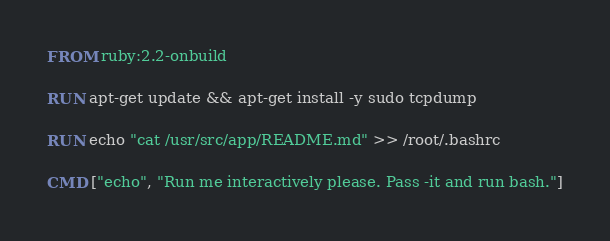Convert code to text. <code><loc_0><loc_0><loc_500><loc_500><_Dockerfile_>FROM ruby:2.2-onbuild

RUN apt-get update && apt-get install -y sudo tcpdump

RUN echo "cat /usr/src/app/README.md" >> /root/.bashrc

CMD ["echo", "Run me interactively please. Pass -it and run bash."]
</code> 